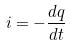Convert formula to latex. <formula><loc_0><loc_0><loc_500><loc_500>i = - \frac { d q } { d t }</formula> 